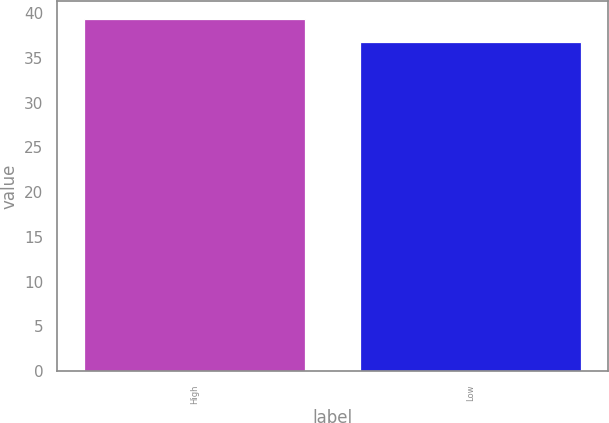Convert chart to OTSL. <chart><loc_0><loc_0><loc_500><loc_500><bar_chart><fcel>High<fcel>Low<nl><fcel>39.37<fcel>36.84<nl></chart> 